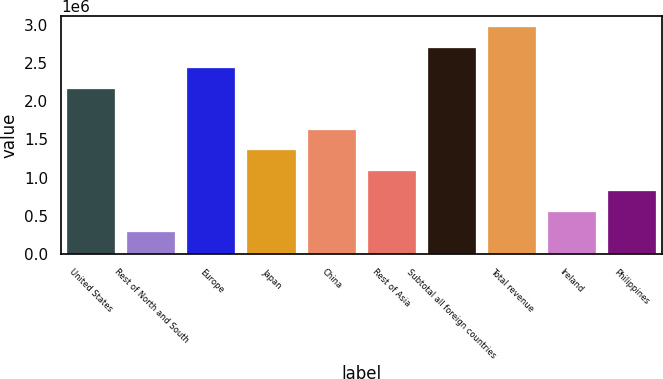<chart> <loc_0><loc_0><loc_500><loc_500><bar_chart><fcel>United States<fcel>Rest of North and South<fcel>Europe<fcel>Japan<fcel>China<fcel>Rest of Asia<fcel>Subtotal all foreign countries<fcel>Total revenue<fcel>Ireland<fcel>Philippines<nl><fcel>2.16362e+06<fcel>282295<fcel>2.43238e+06<fcel>1.35734e+06<fcel>1.6261e+06<fcel>1.08858e+06<fcel>2.70114e+06<fcel>2.9699e+06<fcel>551056<fcel>819816<nl></chart> 